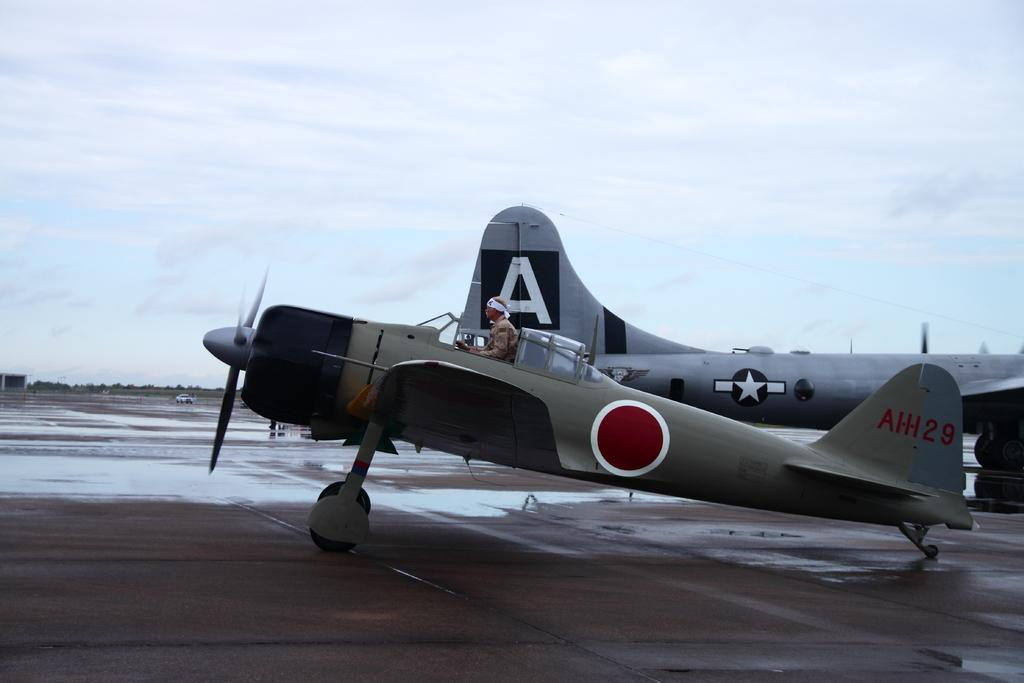What is the person in the image doing? There is a person riding a plane in the image. Where is the plane located in the image? The plane is on a runway. Can you describe any other planes visible in the image? Yes, there is another plane visible on the side in the image. What type of dust can be seen accumulating on the grape in the image? There is no grape or dust present in the image. What scientific principle is being demonstrated in the image? The image does not depict a scientific principle; it shows a person riding a plane on a runway. 